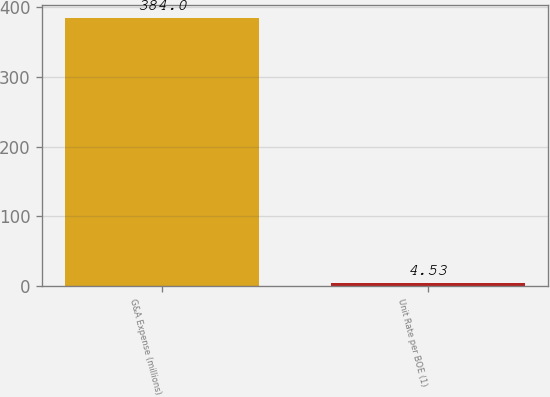Convert chart. <chart><loc_0><loc_0><loc_500><loc_500><bar_chart><fcel>G&A Expense (millions)<fcel>Unit Rate per BOE (1)<nl><fcel>384<fcel>4.53<nl></chart> 